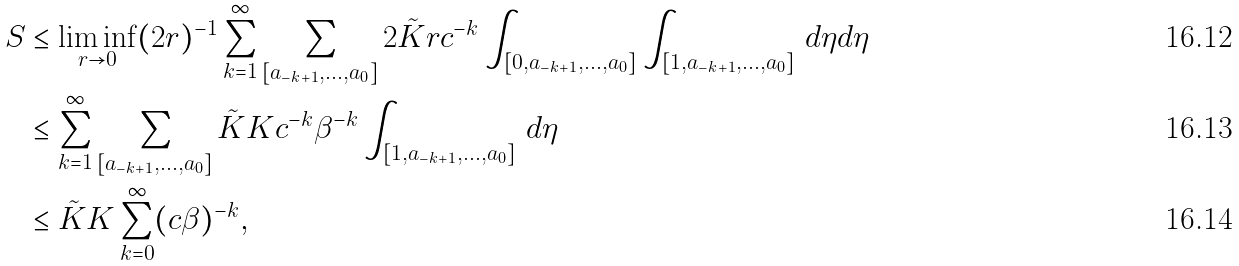Convert formula to latex. <formula><loc_0><loc_0><loc_500><loc_500>S & \leq \liminf _ { r \to 0 } ( 2 r ) ^ { - 1 } \sum _ { k = 1 } ^ { \infty } \sum _ { [ a _ { - k + 1 } , \dots , a _ { 0 } ] } 2 \tilde { K } r c ^ { - k } \int _ { [ 0 , a _ { - k + 1 } , \dots , a _ { 0 } ] } \int _ { [ 1 , a _ { - k + 1 } , \dots , a _ { 0 } ] } \, d \eta d \eta \\ & \leq \sum _ { k = 1 } ^ { \infty } \sum _ { [ a _ { - k + 1 } , \dots , a _ { 0 } ] } \tilde { K } K c ^ { - k } \beta ^ { - k } \int _ { [ 1 , a _ { - k + 1 } , \dots , a _ { 0 } ] } \, d \eta \\ & \leq \tilde { K } K \sum _ { k = 0 } ^ { \infty } ( c \beta ) ^ { - k } ,</formula> 